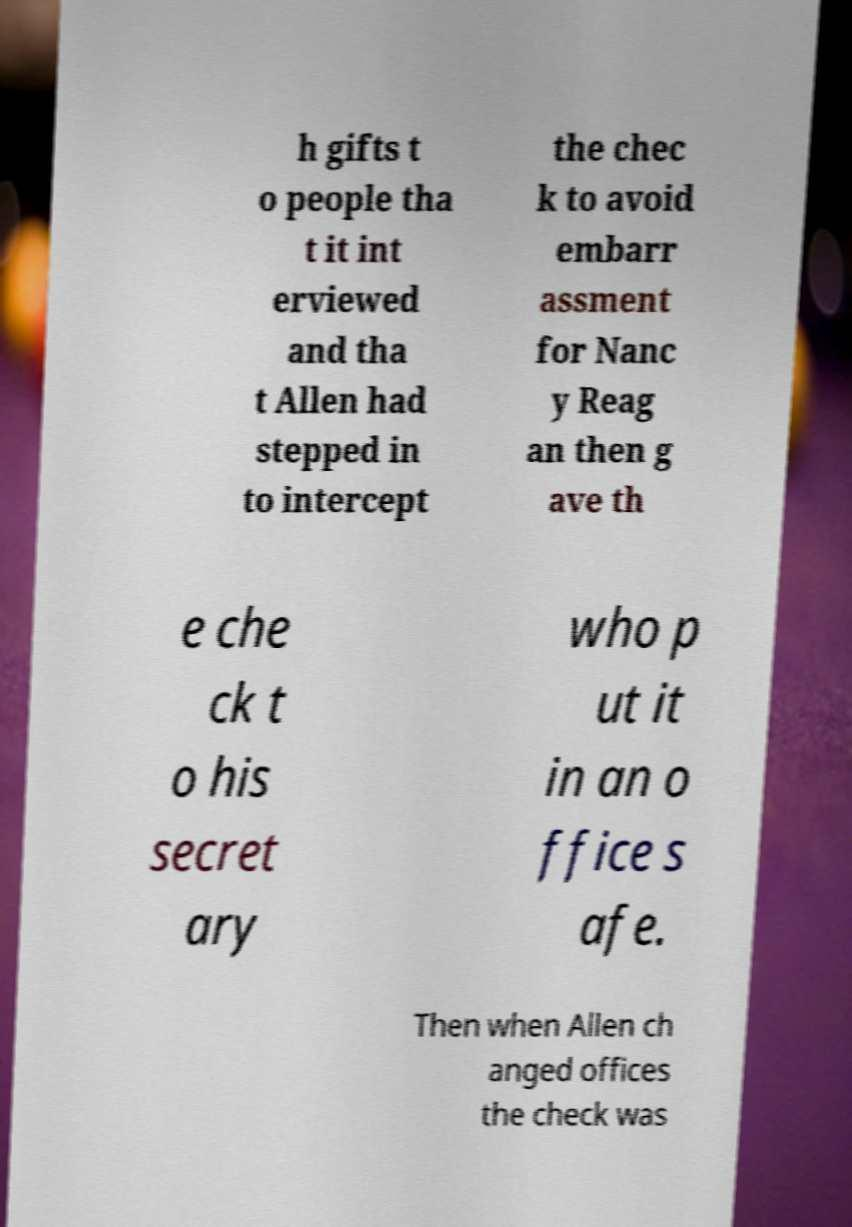Can you accurately transcribe the text from the provided image for me? h gifts t o people tha t it int erviewed and tha t Allen had stepped in to intercept the chec k to avoid embarr assment for Nanc y Reag an then g ave th e che ck t o his secret ary who p ut it in an o ffice s afe. Then when Allen ch anged offices the check was 